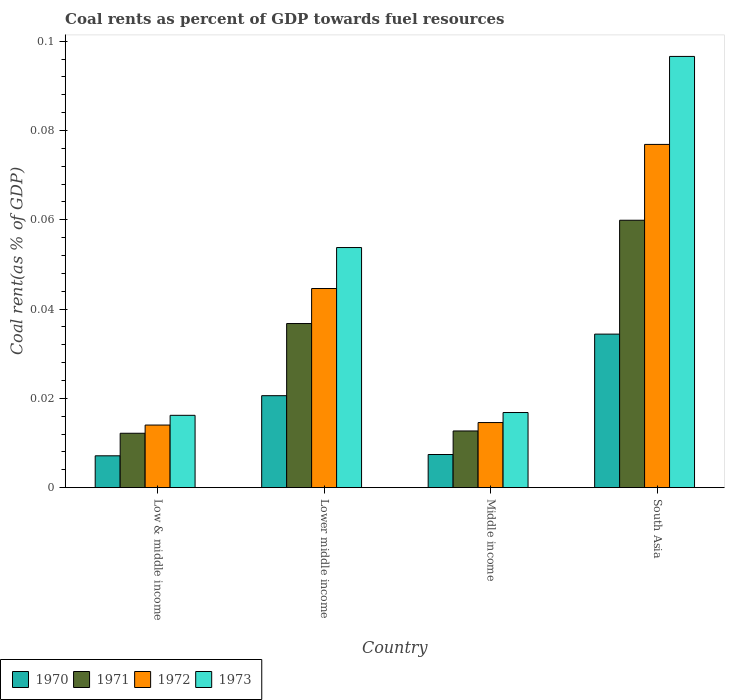How many groups of bars are there?
Your answer should be compact. 4. Are the number of bars on each tick of the X-axis equal?
Keep it short and to the point. Yes. How many bars are there on the 4th tick from the right?
Provide a short and direct response. 4. What is the label of the 3rd group of bars from the left?
Keep it short and to the point. Middle income. In how many cases, is the number of bars for a given country not equal to the number of legend labels?
Your answer should be very brief. 0. What is the coal rent in 1971 in South Asia?
Keep it short and to the point. 0.06. Across all countries, what is the maximum coal rent in 1972?
Make the answer very short. 0.08. Across all countries, what is the minimum coal rent in 1973?
Make the answer very short. 0.02. In which country was the coal rent in 1971 minimum?
Provide a short and direct response. Low & middle income. What is the total coal rent in 1973 in the graph?
Ensure brevity in your answer.  0.18. What is the difference between the coal rent in 1970 in Lower middle income and that in Middle income?
Your answer should be compact. 0.01. What is the difference between the coal rent in 1973 in Lower middle income and the coal rent in 1972 in Middle income?
Keep it short and to the point. 0.04. What is the average coal rent in 1973 per country?
Provide a succinct answer. 0.05. What is the difference between the coal rent of/in 1970 and coal rent of/in 1972 in Lower middle income?
Your response must be concise. -0.02. In how many countries, is the coal rent in 1971 greater than 0.092 %?
Ensure brevity in your answer.  0. What is the ratio of the coal rent in 1972 in Low & middle income to that in South Asia?
Make the answer very short. 0.18. What is the difference between the highest and the second highest coal rent in 1972?
Provide a succinct answer. 0.03. What is the difference between the highest and the lowest coal rent in 1970?
Offer a terse response. 0.03. In how many countries, is the coal rent in 1972 greater than the average coal rent in 1972 taken over all countries?
Give a very brief answer. 2. Is the sum of the coal rent in 1971 in Lower middle income and South Asia greater than the maximum coal rent in 1970 across all countries?
Offer a very short reply. Yes. What does the 3rd bar from the left in Middle income represents?
Your answer should be compact. 1972. What does the 1st bar from the right in Low & middle income represents?
Provide a succinct answer. 1973. Is it the case that in every country, the sum of the coal rent in 1972 and coal rent in 1973 is greater than the coal rent in 1970?
Provide a succinct answer. Yes. How many countries are there in the graph?
Give a very brief answer. 4. What is the difference between two consecutive major ticks on the Y-axis?
Provide a succinct answer. 0.02. Are the values on the major ticks of Y-axis written in scientific E-notation?
Offer a terse response. No. Does the graph contain grids?
Your answer should be compact. No. What is the title of the graph?
Provide a succinct answer. Coal rents as percent of GDP towards fuel resources. What is the label or title of the Y-axis?
Offer a terse response. Coal rent(as % of GDP). What is the Coal rent(as % of GDP) in 1970 in Low & middle income?
Your response must be concise. 0.01. What is the Coal rent(as % of GDP) in 1971 in Low & middle income?
Offer a terse response. 0.01. What is the Coal rent(as % of GDP) in 1972 in Low & middle income?
Make the answer very short. 0.01. What is the Coal rent(as % of GDP) of 1973 in Low & middle income?
Provide a short and direct response. 0.02. What is the Coal rent(as % of GDP) in 1970 in Lower middle income?
Provide a succinct answer. 0.02. What is the Coal rent(as % of GDP) in 1971 in Lower middle income?
Your response must be concise. 0.04. What is the Coal rent(as % of GDP) in 1972 in Lower middle income?
Give a very brief answer. 0.04. What is the Coal rent(as % of GDP) in 1973 in Lower middle income?
Offer a terse response. 0.05. What is the Coal rent(as % of GDP) in 1970 in Middle income?
Your response must be concise. 0.01. What is the Coal rent(as % of GDP) of 1971 in Middle income?
Your answer should be compact. 0.01. What is the Coal rent(as % of GDP) of 1972 in Middle income?
Offer a very short reply. 0.01. What is the Coal rent(as % of GDP) of 1973 in Middle income?
Provide a succinct answer. 0.02. What is the Coal rent(as % of GDP) in 1970 in South Asia?
Your answer should be compact. 0.03. What is the Coal rent(as % of GDP) of 1971 in South Asia?
Provide a succinct answer. 0.06. What is the Coal rent(as % of GDP) in 1972 in South Asia?
Your response must be concise. 0.08. What is the Coal rent(as % of GDP) of 1973 in South Asia?
Make the answer very short. 0.1. Across all countries, what is the maximum Coal rent(as % of GDP) of 1970?
Offer a terse response. 0.03. Across all countries, what is the maximum Coal rent(as % of GDP) of 1971?
Give a very brief answer. 0.06. Across all countries, what is the maximum Coal rent(as % of GDP) of 1972?
Give a very brief answer. 0.08. Across all countries, what is the maximum Coal rent(as % of GDP) of 1973?
Provide a succinct answer. 0.1. Across all countries, what is the minimum Coal rent(as % of GDP) in 1970?
Your answer should be very brief. 0.01. Across all countries, what is the minimum Coal rent(as % of GDP) of 1971?
Make the answer very short. 0.01. Across all countries, what is the minimum Coal rent(as % of GDP) of 1972?
Provide a short and direct response. 0.01. Across all countries, what is the minimum Coal rent(as % of GDP) in 1973?
Make the answer very short. 0.02. What is the total Coal rent(as % of GDP) in 1970 in the graph?
Your answer should be compact. 0.07. What is the total Coal rent(as % of GDP) of 1971 in the graph?
Your response must be concise. 0.12. What is the total Coal rent(as % of GDP) in 1972 in the graph?
Ensure brevity in your answer.  0.15. What is the total Coal rent(as % of GDP) of 1973 in the graph?
Provide a short and direct response. 0.18. What is the difference between the Coal rent(as % of GDP) of 1970 in Low & middle income and that in Lower middle income?
Provide a succinct answer. -0.01. What is the difference between the Coal rent(as % of GDP) in 1971 in Low & middle income and that in Lower middle income?
Offer a very short reply. -0.02. What is the difference between the Coal rent(as % of GDP) of 1972 in Low & middle income and that in Lower middle income?
Keep it short and to the point. -0.03. What is the difference between the Coal rent(as % of GDP) in 1973 in Low & middle income and that in Lower middle income?
Provide a succinct answer. -0.04. What is the difference between the Coal rent(as % of GDP) in 1970 in Low & middle income and that in Middle income?
Your answer should be very brief. -0. What is the difference between the Coal rent(as % of GDP) of 1971 in Low & middle income and that in Middle income?
Offer a very short reply. -0. What is the difference between the Coal rent(as % of GDP) of 1972 in Low & middle income and that in Middle income?
Keep it short and to the point. -0. What is the difference between the Coal rent(as % of GDP) in 1973 in Low & middle income and that in Middle income?
Ensure brevity in your answer.  -0. What is the difference between the Coal rent(as % of GDP) of 1970 in Low & middle income and that in South Asia?
Give a very brief answer. -0.03. What is the difference between the Coal rent(as % of GDP) in 1971 in Low & middle income and that in South Asia?
Give a very brief answer. -0.05. What is the difference between the Coal rent(as % of GDP) of 1972 in Low & middle income and that in South Asia?
Ensure brevity in your answer.  -0.06. What is the difference between the Coal rent(as % of GDP) of 1973 in Low & middle income and that in South Asia?
Your answer should be compact. -0.08. What is the difference between the Coal rent(as % of GDP) in 1970 in Lower middle income and that in Middle income?
Your answer should be very brief. 0.01. What is the difference between the Coal rent(as % of GDP) of 1971 in Lower middle income and that in Middle income?
Offer a very short reply. 0.02. What is the difference between the Coal rent(as % of GDP) of 1973 in Lower middle income and that in Middle income?
Give a very brief answer. 0.04. What is the difference between the Coal rent(as % of GDP) of 1970 in Lower middle income and that in South Asia?
Offer a very short reply. -0.01. What is the difference between the Coal rent(as % of GDP) of 1971 in Lower middle income and that in South Asia?
Your answer should be very brief. -0.02. What is the difference between the Coal rent(as % of GDP) of 1972 in Lower middle income and that in South Asia?
Provide a short and direct response. -0.03. What is the difference between the Coal rent(as % of GDP) of 1973 in Lower middle income and that in South Asia?
Your response must be concise. -0.04. What is the difference between the Coal rent(as % of GDP) in 1970 in Middle income and that in South Asia?
Keep it short and to the point. -0.03. What is the difference between the Coal rent(as % of GDP) in 1971 in Middle income and that in South Asia?
Your response must be concise. -0.05. What is the difference between the Coal rent(as % of GDP) in 1972 in Middle income and that in South Asia?
Make the answer very short. -0.06. What is the difference between the Coal rent(as % of GDP) in 1973 in Middle income and that in South Asia?
Keep it short and to the point. -0.08. What is the difference between the Coal rent(as % of GDP) of 1970 in Low & middle income and the Coal rent(as % of GDP) of 1971 in Lower middle income?
Ensure brevity in your answer.  -0.03. What is the difference between the Coal rent(as % of GDP) of 1970 in Low & middle income and the Coal rent(as % of GDP) of 1972 in Lower middle income?
Make the answer very short. -0.04. What is the difference between the Coal rent(as % of GDP) in 1970 in Low & middle income and the Coal rent(as % of GDP) in 1973 in Lower middle income?
Your response must be concise. -0.05. What is the difference between the Coal rent(as % of GDP) of 1971 in Low & middle income and the Coal rent(as % of GDP) of 1972 in Lower middle income?
Give a very brief answer. -0.03. What is the difference between the Coal rent(as % of GDP) in 1971 in Low & middle income and the Coal rent(as % of GDP) in 1973 in Lower middle income?
Your answer should be very brief. -0.04. What is the difference between the Coal rent(as % of GDP) of 1972 in Low & middle income and the Coal rent(as % of GDP) of 1973 in Lower middle income?
Your answer should be compact. -0.04. What is the difference between the Coal rent(as % of GDP) in 1970 in Low & middle income and the Coal rent(as % of GDP) in 1971 in Middle income?
Your answer should be compact. -0.01. What is the difference between the Coal rent(as % of GDP) of 1970 in Low & middle income and the Coal rent(as % of GDP) of 1972 in Middle income?
Your response must be concise. -0.01. What is the difference between the Coal rent(as % of GDP) in 1970 in Low & middle income and the Coal rent(as % of GDP) in 1973 in Middle income?
Offer a terse response. -0.01. What is the difference between the Coal rent(as % of GDP) of 1971 in Low & middle income and the Coal rent(as % of GDP) of 1972 in Middle income?
Provide a succinct answer. -0. What is the difference between the Coal rent(as % of GDP) of 1971 in Low & middle income and the Coal rent(as % of GDP) of 1973 in Middle income?
Your answer should be compact. -0. What is the difference between the Coal rent(as % of GDP) in 1972 in Low & middle income and the Coal rent(as % of GDP) in 1973 in Middle income?
Offer a very short reply. -0. What is the difference between the Coal rent(as % of GDP) of 1970 in Low & middle income and the Coal rent(as % of GDP) of 1971 in South Asia?
Your response must be concise. -0.05. What is the difference between the Coal rent(as % of GDP) of 1970 in Low & middle income and the Coal rent(as % of GDP) of 1972 in South Asia?
Give a very brief answer. -0.07. What is the difference between the Coal rent(as % of GDP) in 1970 in Low & middle income and the Coal rent(as % of GDP) in 1973 in South Asia?
Offer a very short reply. -0.09. What is the difference between the Coal rent(as % of GDP) in 1971 in Low & middle income and the Coal rent(as % of GDP) in 1972 in South Asia?
Keep it short and to the point. -0.06. What is the difference between the Coal rent(as % of GDP) in 1971 in Low & middle income and the Coal rent(as % of GDP) in 1973 in South Asia?
Provide a succinct answer. -0.08. What is the difference between the Coal rent(as % of GDP) in 1972 in Low & middle income and the Coal rent(as % of GDP) in 1973 in South Asia?
Give a very brief answer. -0.08. What is the difference between the Coal rent(as % of GDP) in 1970 in Lower middle income and the Coal rent(as % of GDP) in 1971 in Middle income?
Your answer should be compact. 0.01. What is the difference between the Coal rent(as % of GDP) of 1970 in Lower middle income and the Coal rent(as % of GDP) of 1972 in Middle income?
Provide a short and direct response. 0.01. What is the difference between the Coal rent(as % of GDP) of 1970 in Lower middle income and the Coal rent(as % of GDP) of 1973 in Middle income?
Offer a terse response. 0. What is the difference between the Coal rent(as % of GDP) in 1971 in Lower middle income and the Coal rent(as % of GDP) in 1972 in Middle income?
Your answer should be compact. 0.02. What is the difference between the Coal rent(as % of GDP) in 1971 in Lower middle income and the Coal rent(as % of GDP) in 1973 in Middle income?
Your answer should be compact. 0.02. What is the difference between the Coal rent(as % of GDP) of 1972 in Lower middle income and the Coal rent(as % of GDP) of 1973 in Middle income?
Keep it short and to the point. 0.03. What is the difference between the Coal rent(as % of GDP) of 1970 in Lower middle income and the Coal rent(as % of GDP) of 1971 in South Asia?
Your answer should be compact. -0.04. What is the difference between the Coal rent(as % of GDP) of 1970 in Lower middle income and the Coal rent(as % of GDP) of 1972 in South Asia?
Your answer should be very brief. -0.06. What is the difference between the Coal rent(as % of GDP) in 1970 in Lower middle income and the Coal rent(as % of GDP) in 1973 in South Asia?
Ensure brevity in your answer.  -0.08. What is the difference between the Coal rent(as % of GDP) in 1971 in Lower middle income and the Coal rent(as % of GDP) in 1972 in South Asia?
Provide a short and direct response. -0.04. What is the difference between the Coal rent(as % of GDP) in 1971 in Lower middle income and the Coal rent(as % of GDP) in 1973 in South Asia?
Your response must be concise. -0.06. What is the difference between the Coal rent(as % of GDP) in 1972 in Lower middle income and the Coal rent(as % of GDP) in 1973 in South Asia?
Offer a terse response. -0.05. What is the difference between the Coal rent(as % of GDP) in 1970 in Middle income and the Coal rent(as % of GDP) in 1971 in South Asia?
Give a very brief answer. -0.05. What is the difference between the Coal rent(as % of GDP) of 1970 in Middle income and the Coal rent(as % of GDP) of 1972 in South Asia?
Your answer should be compact. -0.07. What is the difference between the Coal rent(as % of GDP) in 1970 in Middle income and the Coal rent(as % of GDP) in 1973 in South Asia?
Give a very brief answer. -0.09. What is the difference between the Coal rent(as % of GDP) in 1971 in Middle income and the Coal rent(as % of GDP) in 1972 in South Asia?
Your answer should be compact. -0.06. What is the difference between the Coal rent(as % of GDP) of 1971 in Middle income and the Coal rent(as % of GDP) of 1973 in South Asia?
Your answer should be very brief. -0.08. What is the difference between the Coal rent(as % of GDP) in 1972 in Middle income and the Coal rent(as % of GDP) in 1973 in South Asia?
Offer a very short reply. -0.08. What is the average Coal rent(as % of GDP) of 1970 per country?
Provide a short and direct response. 0.02. What is the average Coal rent(as % of GDP) in 1971 per country?
Your answer should be very brief. 0.03. What is the average Coal rent(as % of GDP) in 1972 per country?
Make the answer very short. 0.04. What is the average Coal rent(as % of GDP) of 1973 per country?
Make the answer very short. 0.05. What is the difference between the Coal rent(as % of GDP) in 1970 and Coal rent(as % of GDP) in 1971 in Low & middle income?
Your answer should be compact. -0.01. What is the difference between the Coal rent(as % of GDP) of 1970 and Coal rent(as % of GDP) of 1972 in Low & middle income?
Provide a short and direct response. -0.01. What is the difference between the Coal rent(as % of GDP) of 1970 and Coal rent(as % of GDP) of 1973 in Low & middle income?
Your answer should be compact. -0.01. What is the difference between the Coal rent(as % of GDP) in 1971 and Coal rent(as % of GDP) in 1972 in Low & middle income?
Offer a terse response. -0. What is the difference between the Coal rent(as % of GDP) in 1971 and Coal rent(as % of GDP) in 1973 in Low & middle income?
Offer a terse response. -0. What is the difference between the Coal rent(as % of GDP) of 1972 and Coal rent(as % of GDP) of 1973 in Low & middle income?
Your answer should be compact. -0. What is the difference between the Coal rent(as % of GDP) of 1970 and Coal rent(as % of GDP) of 1971 in Lower middle income?
Your answer should be very brief. -0.02. What is the difference between the Coal rent(as % of GDP) in 1970 and Coal rent(as % of GDP) in 1972 in Lower middle income?
Make the answer very short. -0.02. What is the difference between the Coal rent(as % of GDP) of 1970 and Coal rent(as % of GDP) of 1973 in Lower middle income?
Provide a succinct answer. -0.03. What is the difference between the Coal rent(as % of GDP) of 1971 and Coal rent(as % of GDP) of 1972 in Lower middle income?
Offer a terse response. -0.01. What is the difference between the Coal rent(as % of GDP) of 1971 and Coal rent(as % of GDP) of 1973 in Lower middle income?
Ensure brevity in your answer.  -0.02. What is the difference between the Coal rent(as % of GDP) of 1972 and Coal rent(as % of GDP) of 1973 in Lower middle income?
Offer a terse response. -0.01. What is the difference between the Coal rent(as % of GDP) in 1970 and Coal rent(as % of GDP) in 1971 in Middle income?
Ensure brevity in your answer.  -0.01. What is the difference between the Coal rent(as % of GDP) of 1970 and Coal rent(as % of GDP) of 1972 in Middle income?
Ensure brevity in your answer.  -0.01. What is the difference between the Coal rent(as % of GDP) in 1970 and Coal rent(as % of GDP) in 1973 in Middle income?
Ensure brevity in your answer.  -0.01. What is the difference between the Coal rent(as % of GDP) of 1971 and Coal rent(as % of GDP) of 1972 in Middle income?
Your answer should be compact. -0. What is the difference between the Coal rent(as % of GDP) in 1971 and Coal rent(as % of GDP) in 1973 in Middle income?
Your answer should be very brief. -0. What is the difference between the Coal rent(as % of GDP) in 1972 and Coal rent(as % of GDP) in 1973 in Middle income?
Your answer should be compact. -0. What is the difference between the Coal rent(as % of GDP) in 1970 and Coal rent(as % of GDP) in 1971 in South Asia?
Offer a very short reply. -0.03. What is the difference between the Coal rent(as % of GDP) of 1970 and Coal rent(as % of GDP) of 1972 in South Asia?
Give a very brief answer. -0.04. What is the difference between the Coal rent(as % of GDP) of 1970 and Coal rent(as % of GDP) of 1973 in South Asia?
Offer a terse response. -0.06. What is the difference between the Coal rent(as % of GDP) in 1971 and Coal rent(as % of GDP) in 1972 in South Asia?
Offer a very short reply. -0.02. What is the difference between the Coal rent(as % of GDP) of 1971 and Coal rent(as % of GDP) of 1973 in South Asia?
Give a very brief answer. -0.04. What is the difference between the Coal rent(as % of GDP) in 1972 and Coal rent(as % of GDP) in 1973 in South Asia?
Give a very brief answer. -0.02. What is the ratio of the Coal rent(as % of GDP) of 1970 in Low & middle income to that in Lower middle income?
Provide a short and direct response. 0.35. What is the ratio of the Coal rent(as % of GDP) of 1971 in Low & middle income to that in Lower middle income?
Offer a very short reply. 0.33. What is the ratio of the Coal rent(as % of GDP) in 1972 in Low & middle income to that in Lower middle income?
Ensure brevity in your answer.  0.31. What is the ratio of the Coal rent(as % of GDP) in 1973 in Low & middle income to that in Lower middle income?
Offer a terse response. 0.3. What is the ratio of the Coal rent(as % of GDP) in 1970 in Low & middle income to that in Middle income?
Keep it short and to the point. 0.96. What is the ratio of the Coal rent(as % of GDP) in 1971 in Low & middle income to that in Middle income?
Provide a short and direct response. 0.96. What is the ratio of the Coal rent(as % of GDP) of 1972 in Low & middle income to that in Middle income?
Provide a short and direct response. 0.96. What is the ratio of the Coal rent(as % of GDP) of 1973 in Low & middle income to that in Middle income?
Ensure brevity in your answer.  0.96. What is the ratio of the Coal rent(as % of GDP) in 1970 in Low & middle income to that in South Asia?
Give a very brief answer. 0.21. What is the ratio of the Coal rent(as % of GDP) in 1971 in Low & middle income to that in South Asia?
Provide a succinct answer. 0.2. What is the ratio of the Coal rent(as % of GDP) in 1972 in Low & middle income to that in South Asia?
Make the answer very short. 0.18. What is the ratio of the Coal rent(as % of GDP) in 1973 in Low & middle income to that in South Asia?
Your answer should be very brief. 0.17. What is the ratio of the Coal rent(as % of GDP) in 1970 in Lower middle income to that in Middle income?
Make the answer very short. 2.78. What is the ratio of the Coal rent(as % of GDP) in 1971 in Lower middle income to that in Middle income?
Keep it short and to the point. 2.9. What is the ratio of the Coal rent(as % of GDP) of 1972 in Lower middle income to that in Middle income?
Offer a terse response. 3.06. What is the ratio of the Coal rent(as % of GDP) in 1973 in Lower middle income to that in Middle income?
Your response must be concise. 3.2. What is the ratio of the Coal rent(as % of GDP) of 1970 in Lower middle income to that in South Asia?
Your response must be concise. 0.6. What is the ratio of the Coal rent(as % of GDP) of 1971 in Lower middle income to that in South Asia?
Offer a very short reply. 0.61. What is the ratio of the Coal rent(as % of GDP) in 1972 in Lower middle income to that in South Asia?
Ensure brevity in your answer.  0.58. What is the ratio of the Coal rent(as % of GDP) in 1973 in Lower middle income to that in South Asia?
Ensure brevity in your answer.  0.56. What is the ratio of the Coal rent(as % of GDP) of 1970 in Middle income to that in South Asia?
Make the answer very short. 0.22. What is the ratio of the Coal rent(as % of GDP) in 1971 in Middle income to that in South Asia?
Make the answer very short. 0.21. What is the ratio of the Coal rent(as % of GDP) in 1972 in Middle income to that in South Asia?
Your answer should be very brief. 0.19. What is the ratio of the Coal rent(as % of GDP) of 1973 in Middle income to that in South Asia?
Give a very brief answer. 0.17. What is the difference between the highest and the second highest Coal rent(as % of GDP) in 1970?
Offer a terse response. 0.01. What is the difference between the highest and the second highest Coal rent(as % of GDP) in 1971?
Your answer should be very brief. 0.02. What is the difference between the highest and the second highest Coal rent(as % of GDP) of 1972?
Ensure brevity in your answer.  0.03. What is the difference between the highest and the second highest Coal rent(as % of GDP) in 1973?
Offer a terse response. 0.04. What is the difference between the highest and the lowest Coal rent(as % of GDP) in 1970?
Give a very brief answer. 0.03. What is the difference between the highest and the lowest Coal rent(as % of GDP) of 1971?
Your answer should be very brief. 0.05. What is the difference between the highest and the lowest Coal rent(as % of GDP) of 1972?
Your response must be concise. 0.06. What is the difference between the highest and the lowest Coal rent(as % of GDP) in 1973?
Your response must be concise. 0.08. 